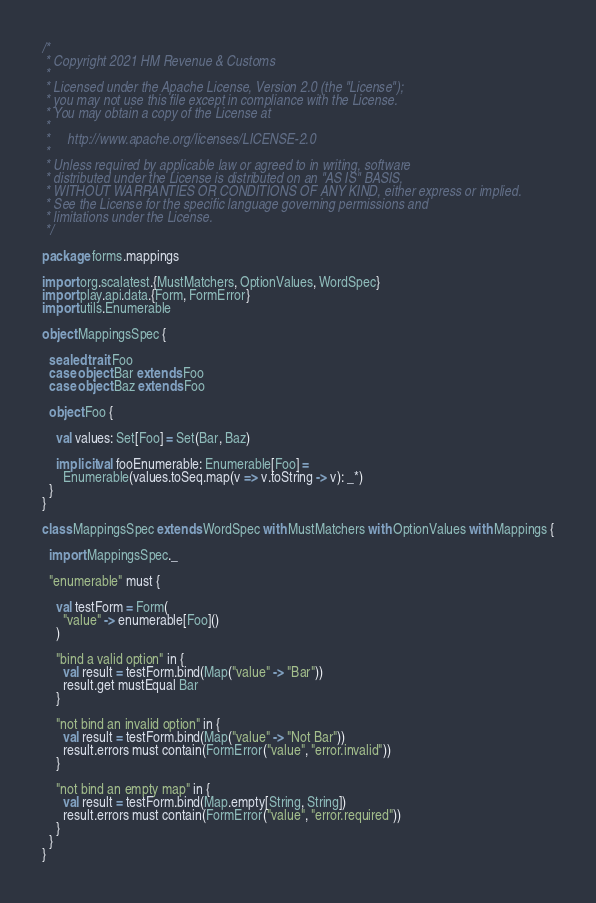Convert code to text. <code><loc_0><loc_0><loc_500><loc_500><_Scala_>/*
 * Copyright 2021 HM Revenue & Customs
 *
 * Licensed under the Apache License, Version 2.0 (the "License");
 * you may not use this file except in compliance with the License.
 * You may obtain a copy of the License at
 *
 *     http://www.apache.org/licenses/LICENSE-2.0
 *
 * Unless required by applicable law or agreed to in writing, software
 * distributed under the License is distributed on an "AS IS" BASIS,
 * WITHOUT WARRANTIES OR CONDITIONS OF ANY KIND, either express or implied.
 * See the License for the specific language governing permissions and
 * limitations under the License.
 */

package forms.mappings

import org.scalatest.{MustMatchers, OptionValues, WordSpec}
import play.api.data.{Form, FormError}
import utils.Enumerable

object MappingsSpec {

  sealed trait Foo
  case object Bar extends Foo
  case object Baz extends Foo

  object Foo {

    val values: Set[Foo] = Set(Bar, Baz)

    implicit val fooEnumerable: Enumerable[Foo] =
      Enumerable(values.toSeq.map(v => v.toString -> v): _*)
  }
}

class MappingsSpec extends WordSpec with MustMatchers with OptionValues with Mappings {

  import MappingsSpec._

  "enumerable" must {

    val testForm = Form(
      "value" -> enumerable[Foo]()
    )

    "bind a valid option" in {
      val result = testForm.bind(Map("value" -> "Bar"))
      result.get mustEqual Bar
    }

    "not bind an invalid option" in {
      val result = testForm.bind(Map("value" -> "Not Bar"))
      result.errors must contain(FormError("value", "error.invalid"))
    }

    "not bind an empty map" in {
      val result = testForm.bind(Map.empty[String, String])
      result.errors must contain(FormError("value", "error.required"))
    }
  }
}
</code> 